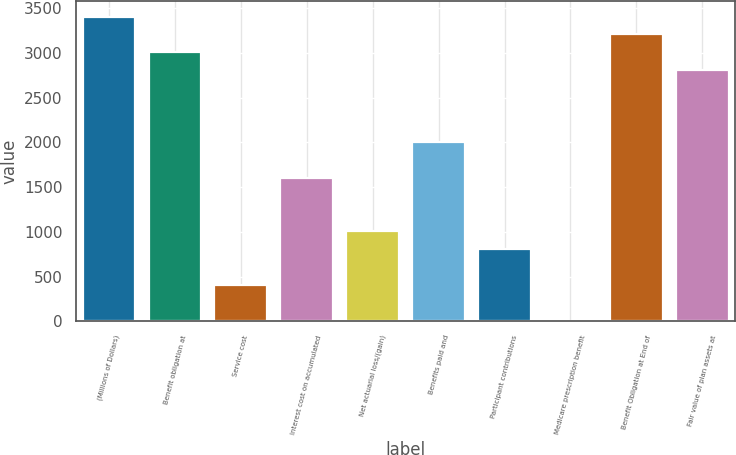<chart> <loc_0><loc_0><loc_500><loc_500><bar_chart><fcel>(Millions of Dollars)<fcel>Benefit obligation at<fcel>Service cost<fcel>Interest cost on accumulated<fcel>Net actuarial loss/(gain)<fcel>Benefits paid and<fcel>Participant contributions<fcel>Medicare prescription benefit<fcel>Benefit Obligation at End of<fcel>Fair value of plan assets at<nl><fcel>3405.6<fcel>3006<fcel>408.6<fcel>1607.4<fcel>1008<fcel>2007<fcel>808.2<fcel>9<fcel>3205.8<fcel>2806.2<nl></chart> 